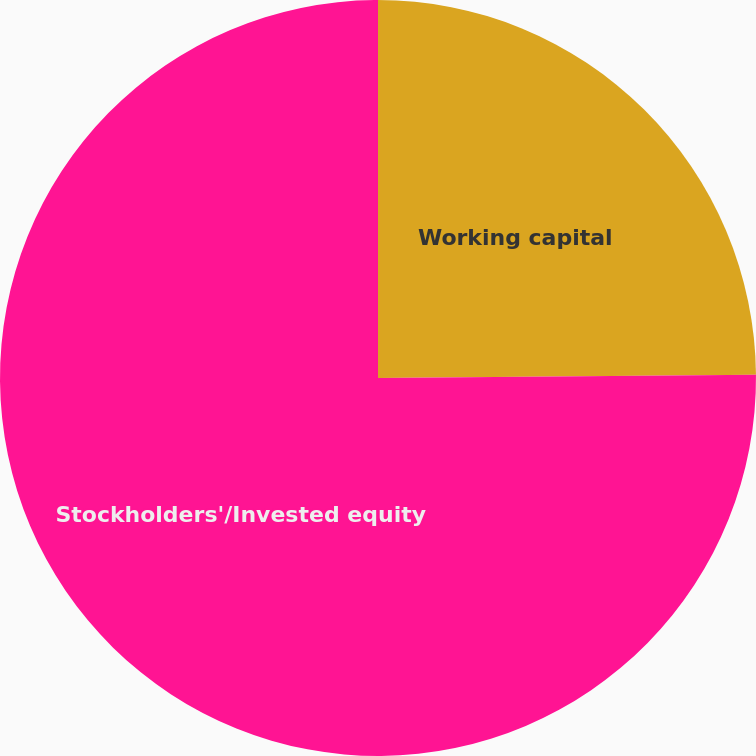<chart> <loc_0><loc_0><loc_500><loc_500><pie_chart><fcel>Working capital<fcel>Stockholders'/Invested equity<nl><fcel>24.86%<fcel>75.14%<nl></chart> 